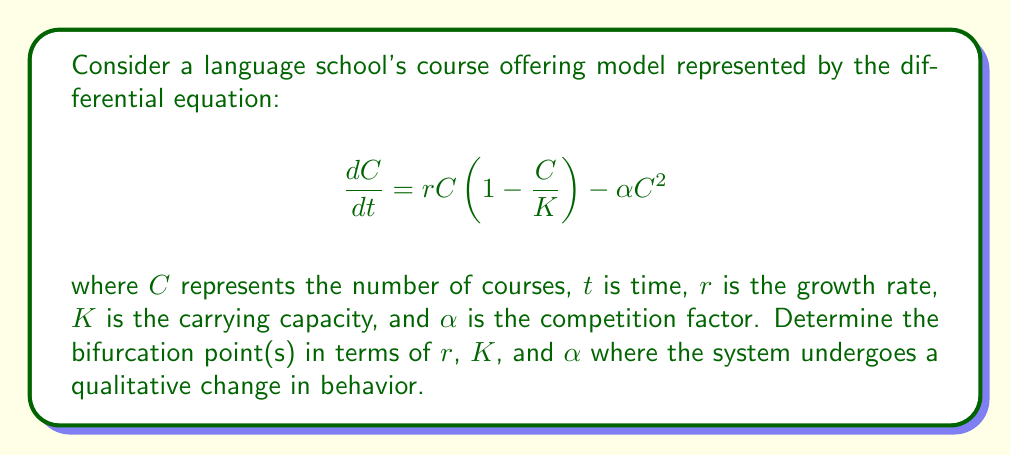Teach me how to tackle this problem. 1) First, we need to find the equilibrium points by setting $\frac{dC}{dt} = 0$:

   $$rC(1 - \frac{C}{K}) - \alpha C^2 = 0$$

2) Factor out $C$:

   $$C(r(1 - \frac{C}{K}) - \alpha C) = 0$$

3) Solve for $C$:
   
   $C = 0$ or $r(1 - \frac{C}{K}) - \alpha C = 0$

4) For the non-zero equilibrium, solve:

   $$r - \frac{rC}{K} - \alpha C = 0$$
   $$r = C(\frac{r}{K} + \alpha)$$
   $$C = \frac{r}{\frac{r}{K} + \alpha} = \frac{rK}{r + \alpha K}$$

5) The bifurcation occurs when this non-zero equilibrium coincides with the zero equilibrium, i.e., when $\frac{rK}{r + \alpha K} = 0$

6) This happens when the numerator is zero while the denominator is non-zero:

   $rK = 0$ and $r + \alpha K \neq 0$

7) Since $K \neq 0$ (carrying capacity is always positive), this occurs when $r = 0$

8) Therefore, the bifurcation point is at $r = 0$

This represents a transcritical bifurcation, where the stability of the zero equilibrium changes.
Answer: $r = 0$ 